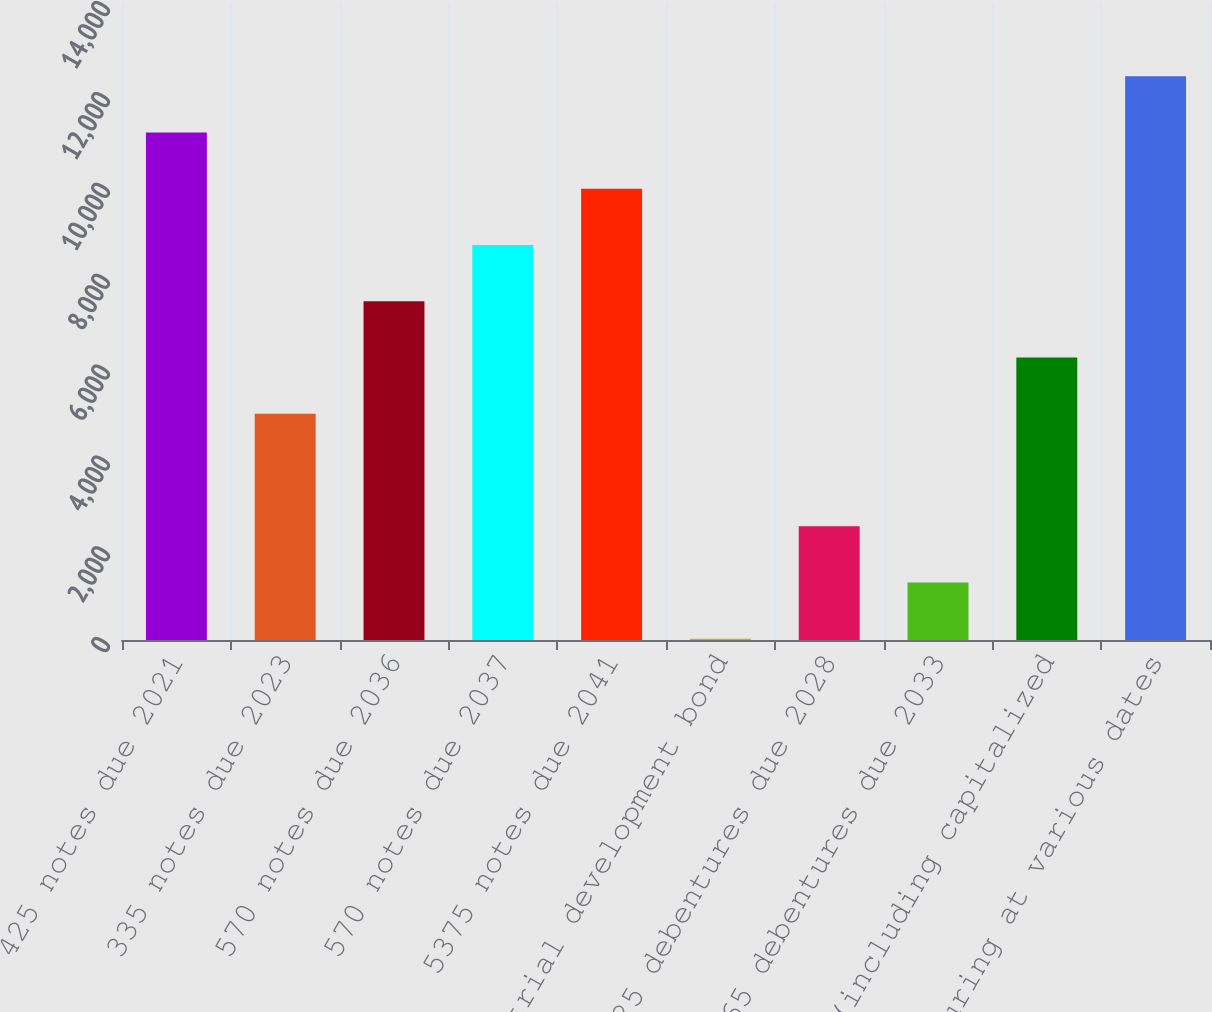Convert chart to OTSL. <chart><loc_0><loc_0><loc_500><loc_500><bar_chart><fcel>425 notes due 2021<fcel>335 notes due 2023<fcel>570 notes due 2036<fcel>570 notes due 2037<fcel>5375 notes due 2041<fcel>Industrial development bond<fcel>6625 debentures due 2028<fcel>9065 debentures due 2033<fcel>Other (including capitalized<fcel>82 maturing at various dates<nl><fcel>11171.1<fcel>4981.6<fcel>7457.4<fcel>8695.3<fcel>9933.2<fcel>30<fcel>2505.8<fcel>1267.9<fcel>6219.5<fcel>12409<nl></chart> 